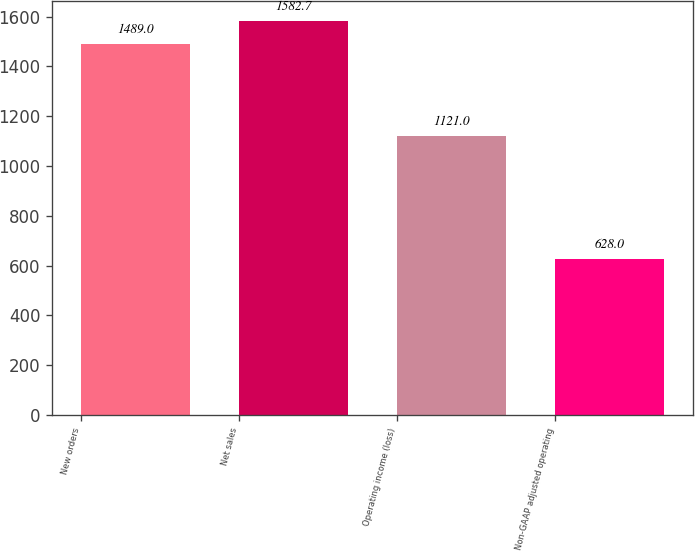Convert chart to OTSL. <chart><loc_0><loc_0><loc_500><loc_500><bar_chart><fcel>New orders<fcel>Net sales<fcel>Operating income (loss)<fcel>Non-GAAP adjusted operating<nl><fcel>1489<fcel>1582.7<fcel>1121<fcel>628<nl></chart> 